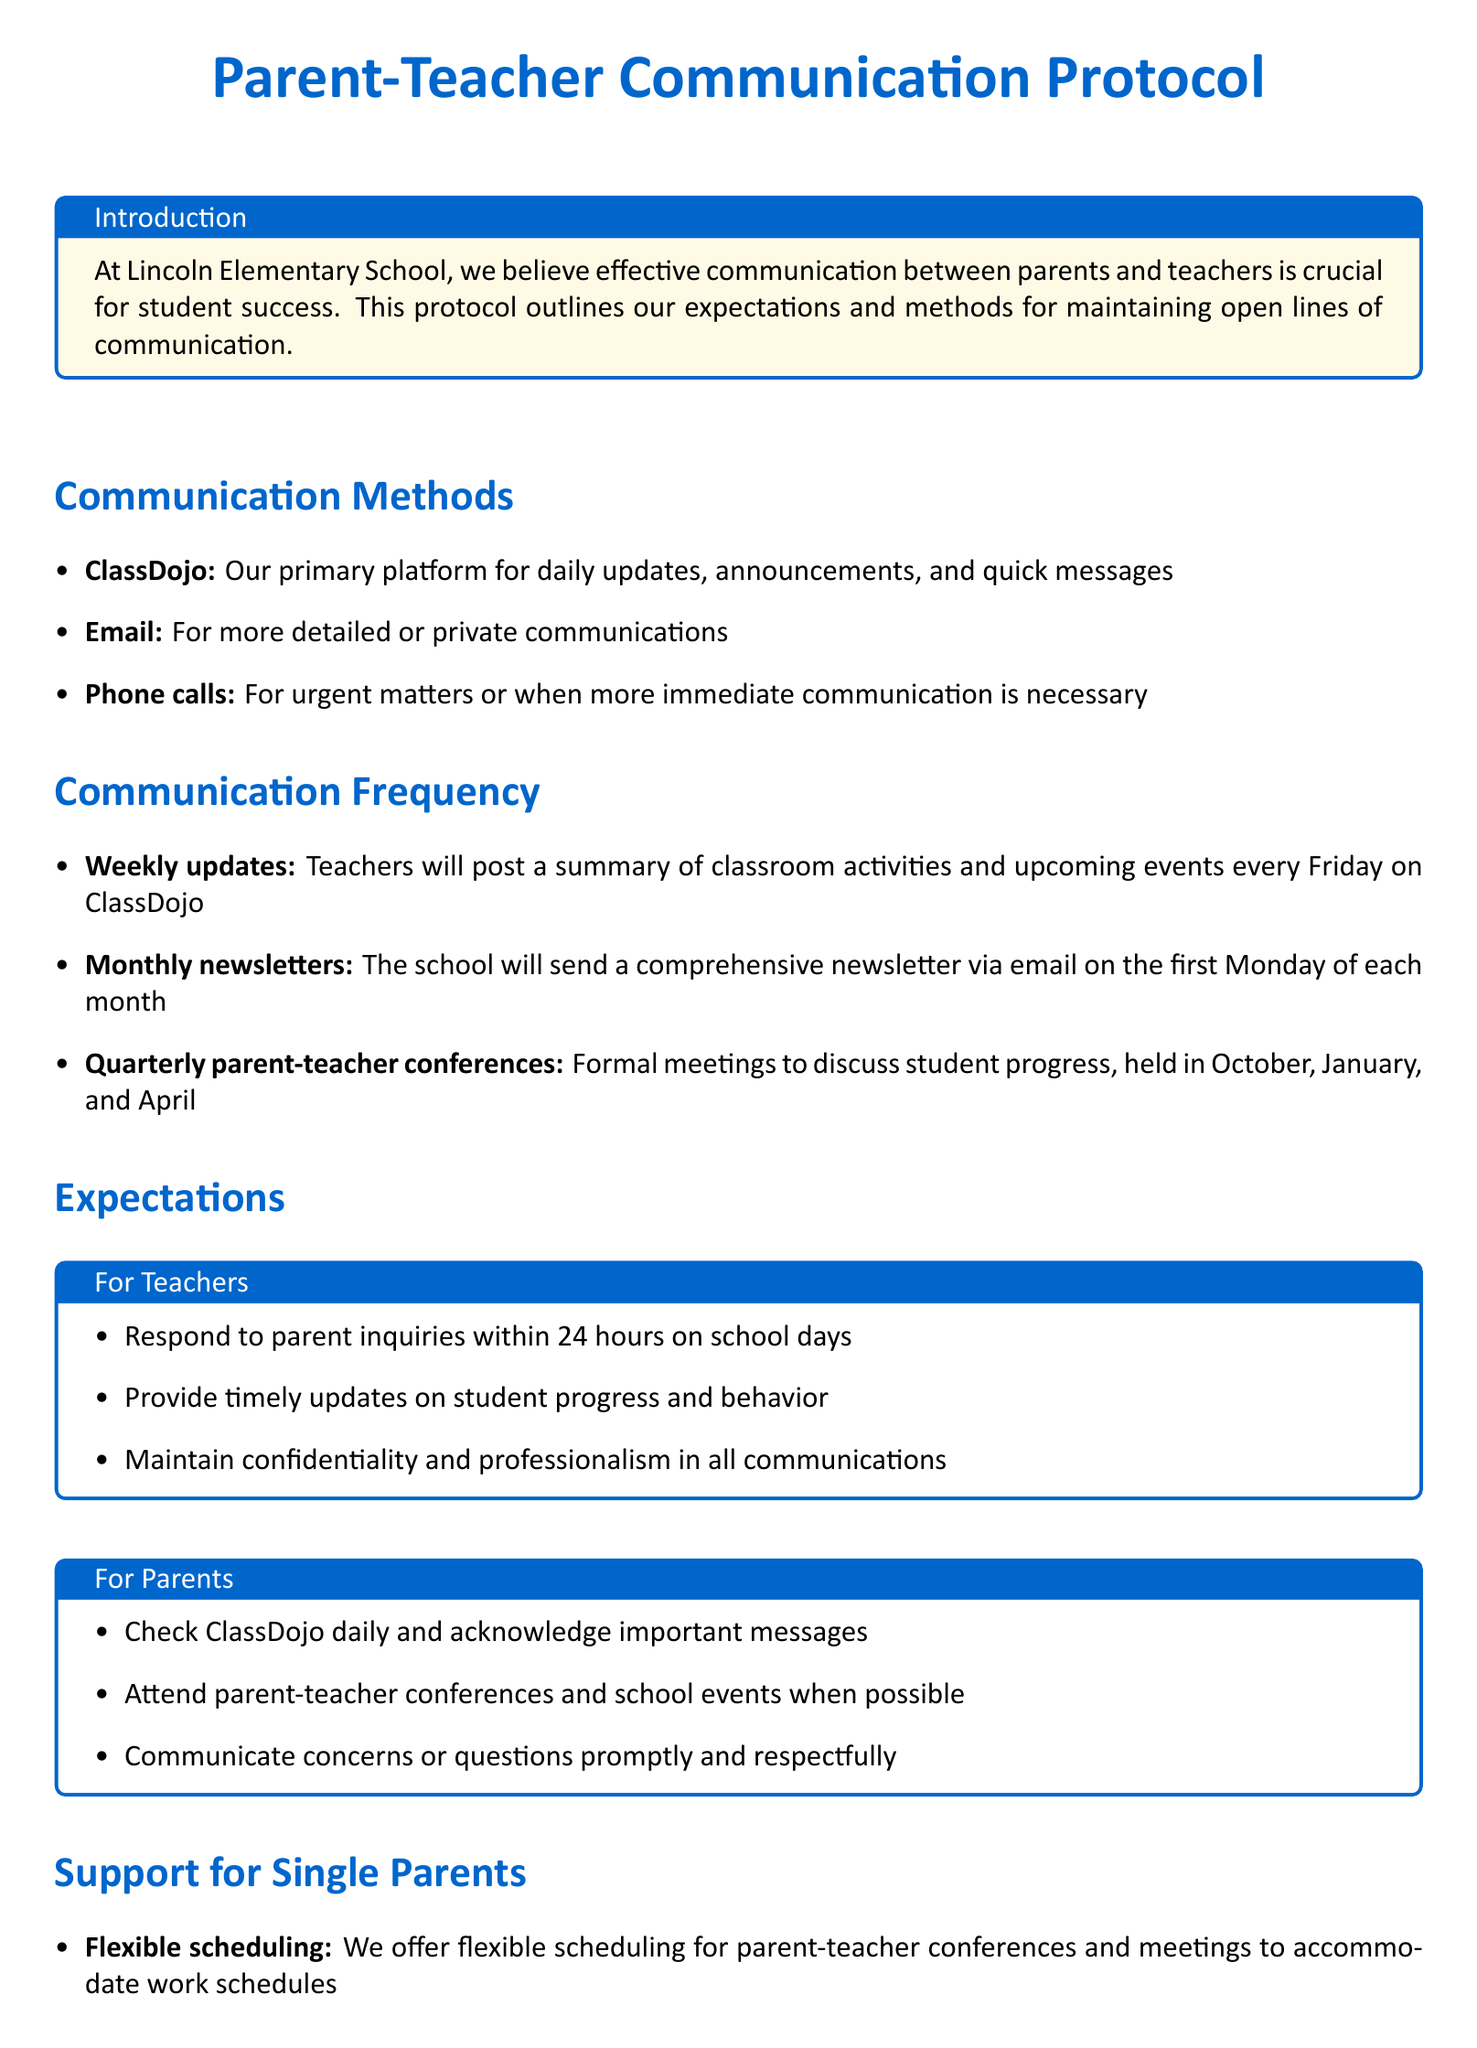What is the primary platform for communication? The document states that ClassDojo is the primary platform for daily updates and messages.
Answer: ClassDojo How often are monthly newsletters sent? According to the document, monthly newsletters are sent via email on the first Monday of each month.
Answer: Monthly What is the frequency of parent-teacher conferences? The document mentions that parent-teacher conferences are held quarterly in October, January, and April.
Answer: Quarterly What is the response time for teachers to parent inquiries? The document specifies that teachers are expected to respond within 24 hours on school days.
Answer: 24 hours What support is offered for single parents? The document outlines several supports for single parents, including flexible scheduling and a resource center.
Answer: Flexible scheduling How soon do teachers provide updates on student progress? The document indicates that teachers provide timely updates on student progress and behavior.
Answer: Timely What should parents check daily? The document states that parents should check ClassDojo daily and acknowledge important messages.
Answer: ClassDojo What time of the week do teachers post weekly updates? The document mentions that teachers will post weekly updates every Friday on ClassDojo.
Answer: Friday 